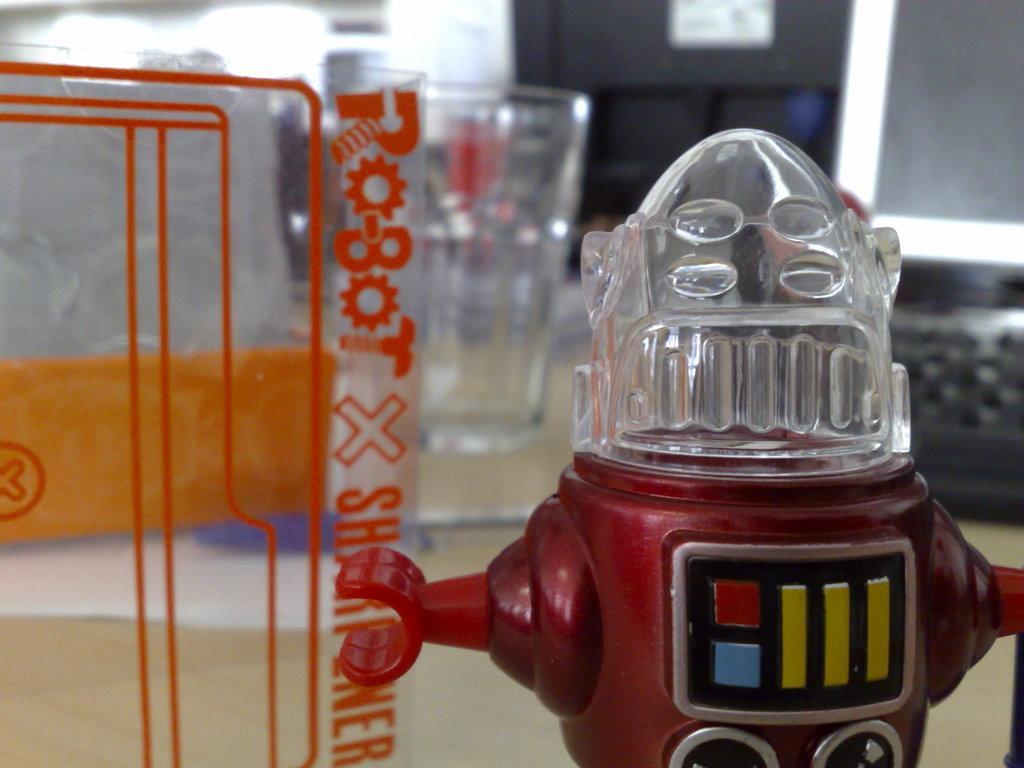<image>
Create a compact narrative representing the image presented. Red robot behind a window that says "Robot x" on it. 